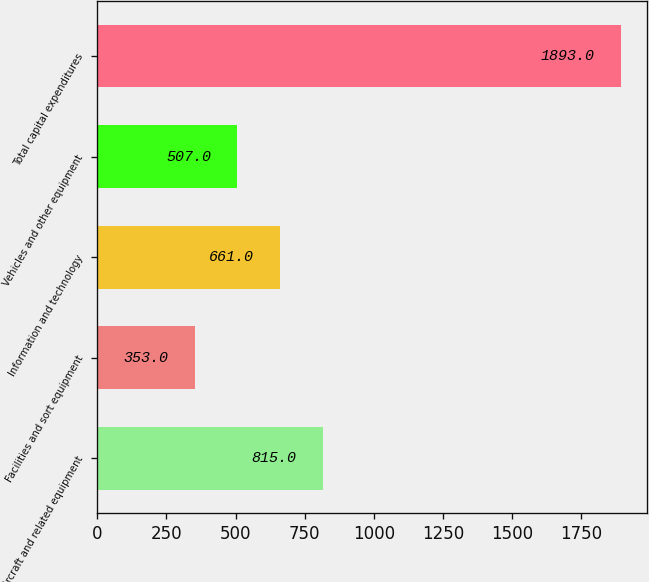<chart> <loc_0><loc_0><loc_500><loc_500><bar_chart><fcel>Aircraft and related equipment<fcel>Facilities and sort equipment<fcel>Information and technology<fcel>Vehicles and other equipment<fcel>Total capital expenditures<nl><fcel>815<fcel>353<fcel>661<fcel>507<fcel>1893<nl></chart> 